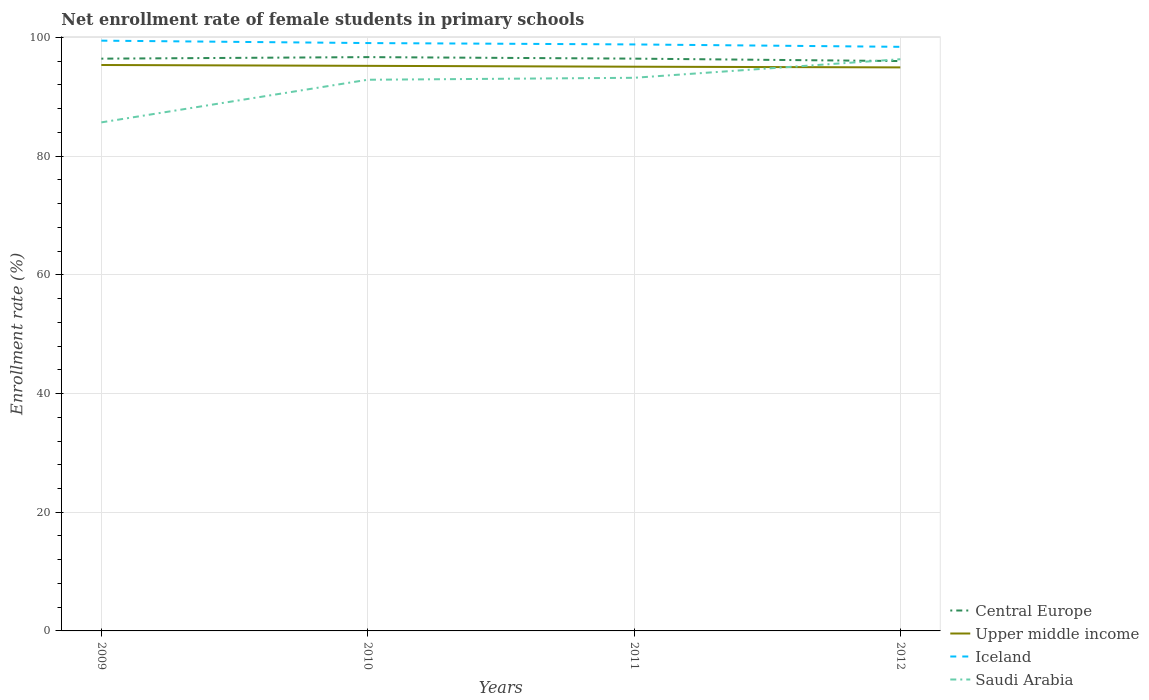How many different coloured lines are there?
Your answer should be compact. 4. Does the line corresponding to Central Europe intersect with the line corresponding to Saudi Arabia?
Your response must be concise. Yes. Across all years, what is the maximum net enrollment rate of female students in primary schools in Upper middle income?
Your response must be concise. 94.97. In which year was the net enrollment rate of female students in primary schools in Upper middle income maximum?
Make the answer very short. 2012. What is the total net enrollment rate of female students in primary schools in Saudi Arabia in the graph?
Give a very brief answer. -10.64. What is the difference between the highest and the second highest net enrollment rate of female students in primary schools in Iceland?
Your answer should be very brief. 1.04. What is the difference between the highest and the lowest net enrollment rate of female students in primary schools in Iceland?
Offer a very short reply. 2. Is the net enrollment rate of female students in primary schools in Iceland strictly greater than the net enrollment rate of female students in primary schools in Upper middle income over the years?
Offer a very short reply. No. How many lines are there?
Provide a succinct answer. 4. What is the difference between two consecutive major ticks on the Y-axis?
Your response must be concise. 20. Are the values on the major ticks of Y-axis written in scientific E-notation?
Make the answer very short. No. Does the graph contain any zero values?
Offer a very short reply. No. Does the graph contain grids?
Give a very brief answer. Yes. What is the title of the graph?
Provide a succinct answer. Net enrollment rate of female students in primary schools. What is the label or title of the X-axis?
Offer a terse response. Years. What is the label or title of the Y-axis?
Your answer should be compact. Enrollment rate (%). What is the Enrollment rate (%) in Central Europe in 2009?
Offer a very short reply. 96.44. What is the Enrollment rate (%) in Upper middle income in 2009?
Make the answer very short. 95.37. What is the Enrollment rate (%) of Iceland in 2009?
Ensure brevity in your answer.  99.47. What is the Enrollment rate (%) of Saudi Arabia in 2009?
Keep it short and to the point. 85.7. What is the Enrollment rate (%) in Central Europe in 2010?
Provide a short and direct response. 96.7. What is the Enrollment rate (%) in Upper middle income in 2010?
Keep it short and to the point. 95.23. What is the Enrollment rate (%) in Iceland in 2010?
Your response must be concise. 99.07. What is the Enrollment rate (%) of Saudi Arabia in 2010?
Keep it short and to the point. 92.88. What is the Enrollment rate (%) in Central Europe in 2011?
Ensure brevity in your answer.  96.44. What is the Enrollment rate (%) of Upper middle income in 2011?
Make the answer very short. 95.08. What is the Enrollment rate (%) of Iceland in 2011?
Keep it short and to the point. 98.84. What is the Enrollment rate (%) of Saudi Arabia in 2011?
Give a very brief answer. 93.21. What is the Enrollment rate (%) in Central Europe in 2012?
Your response must be concise. 96.03. What is the Enrollment rate (%) in Upper middle income in 2012?
Ensure brevity in your answer.  94.97. What is the Enrollment rate (%) of Iceland in 2012?
Your response must be concise. 98.43. What is the Enrollment rate (%) in Saudi Arabia in 2012?
Provide a short and direct response. 96.35. Across all years, what is the maximum Enrollment rate (%) of Central Europe?
Ensure brevity in your answer.  96.7. Across all years, what is the maximum Enrollment rate (%) of Upper middle income?
Your response must be concise. 95.37. Across all years, what is the maximum Enrollment rate (%) of Iceland?
Make the answer very short. 99.47. Across all years, what is the maximum Enrollment rate (%) in Saudi Arabia?
Your answer should be very brief. 96.35. Across all years, what is the minimum Enrollment rate (%) in Central Europe?
Keep it short and to the point. 96.03. Across all years, what is the minimum Enrollment rate (%) in Upper middle income?
Your answer should be compact. 94.97. Across all years, what is the minimum Enrollment rate (%) of Iceland?
Your answer should be compact. 98.43. Across all years, what is the minimum Enrollment rate (%) in Saudi Arabia?
Keep it short and to the point. 85.7. What is the total Enrollment rate (%) of Central Europe in the graph?
Give a very brief answer. 385.61. What is the total Enrollment rate (%) of Upper middle income in the graph?
Your answer should be compact. 380.65. What is the total Enrollment rate (%) of Iceland in the graph?
Offer a terse response. 395.81. What is the total Enrollment rate (%) in Saudi Arabia in the graph?
Your response must be concise. 368.14. What is the difference between the Enrollment rate (%) of Central Europe in 2009 and that in 2010?
Your answer should be compact. -0.26. What is the difference between the Enrollment rate (%) in Upper middle income in 2009 and that in 2010?
Provide a short and direct response. 0.14. What is the difference between the Enrollment rate (%) of Iceland in 2009 and that in 2010?
Provide a succinct answer. 0.4. What is the difference between the Enrollment rate (%) of Saudi Arabia in 2009 and that in 2010?
Your response must be concise. -7.18. What is the difference between the Enrollment rate (%) of Central Europe in 2009 and that in 2011?
Your answer should be compact. -0.01. What is the difference between the Enrollment rate (%) in Upper middle income in 2009 and that in 2011?
Provide a succinct answer. 0.29. What is the difference between the Enrollment rate (%) of Iceland in 2009 and that in 2011?
Offer a very short reply. 0.64. What is the difference between the Enrollment rate (%) of Saudi Arabia in 2009 and that in 2011?
Give a very brief answer. -7.51. What is the difference between the Enrollment rate (%) in Central Europe in 2009 and that in 2012?
Give a very brief answer. 0.4. What is the difference between the Enrollment rate (%) in Upper middle income in 2009 and that in 2012?
Give a very brief answer. 0.4. What is the difference between the Enrollment rate (%) in Iceland in 2009 and that in 2012?
Provide a succinct answer. 1.04. What is the difference between the Enrollment rate (%) of Saudi Arabia in 2009 and that in 2012?
Provide a succinct answer. -10.64. What is the difference between the Enrollment rate (%) of Central Europe in 2010 and that in 2011?
Give a very brief answer. 0.26. What is the difference between the Enrollment rate (%) in Upper middle income in 2010 and that in 2011?
Ensure brevity in your answer.  0.15. What is the difference between the Enrollment rate (%) in Iceland in 2010 and that in 2011?
Offer a very short reply. 0.23. What is the difference between the Enrollment rate (%) in Saudi Arabia in 2010 and that in 2011?
Offer a very short reply. -0.33. What is the difference between the Enrollment rate (%) of Central Europe in 2010 and that in 2012?
Offer a very short reply. 0.66. What is the difference between the Enrollment rate (%) of Upper middle income in 2010 and that in 2012?
Offer a very short reply. 0.26. What is the difference between the Enrollment rate (%) of Iceland in 2010 and that in 2012?
Provide a short and direct response. 0.64. What is the difference between the Enrollment rate (%) in Saudi Arabia in 2010 and that in 2012?
Offer a very short reply. -3.46. What is the difference between the Enrollment rate (%) of Central Europe in 2011 and that in 2012?
Your response must be concise. 0.41. What is the difference between the Enrollment rate (%) of Upper middle income in 2011 and that in 2012?
Provide a succinct answer. 0.12. What is the difference between the Enrollment rate (%) of Iceland in 2011 and that in 2012?
Keep it short and to the point. 0.4. What is the difference between the Enrollment rate (%) in Saudi Arabia in 2011 and that in 2012?
Your answer should be very brief. -3.13. What is the difference between the Enrollment rate (%) in Central Europe in 2009 and the Enrollment rate (%) in Upper middle income in 2010?
Offer a very short reply. 1.21. What is the difference between the Enrollment rate (%) in Central Europe in 2009 and the Enrollment rate (%) in Iceland in 2010?
Provide a succinct answer. -2.63. What is the difference between the Enrollment rate (%) of Central Europe in 2009 and the Enrollment rate (%) of Saudi Arabia in 2010?
Ensure brevity in your answer.  3.56. What is the difference between the Enrollment rate (%) of Upper middle income in 2009 and the Enrollment rate (%) of Iceland in 2010?
Provide a short and direct response. -3.7. What is the difference between the Enrollment rate (%) of Upper middle income in 2009 and the Enrollment rate (%) of Saudi Arabia in 2010?
Provide a short and direct response. 2.49. What is the difference between the Enrollment rate (%) of Iceland in 2009 and the Enrollment rate (%) of Saudi Arabia in 2010?
Your answer should be very brief. 6.59. What is the difference between the Enrollment rate (%) of Central Europe in 2009 and the Enrollment rate (%) of Upper middle income in 2011?
Ensure brevity in your answer.  1.36. What is the difference between the Enrollment rate (%) of Central Europe in 2009 and the Enrollment rate (%) of Iceland in 2011?
Ensure brevity in your answer.  -2.4. What is the difference between the Enrollment rate (%) of Central Europe in 2009 and the Enrollment rate (%) of Saudi Arabia in 2011?
Give a very brief answer. 3.22. What is the difference between the Enrollment rate (%) in Upper middle income in 2009 and the Enrollment rate (%) in Iceland in 2011?
Provide a short and direct response. -3.47. What is the difference between the Enrollment rate (%) in Upper middle income in 2009 and the Enrollment rate (%) in Saudi Arabia in 2011?
Provide a succinct answer. 2.16. What is the difference between the Enrollment rate (%) of Iceland in 2009 and the Enrollment rate (%) of Saudi Arabia in 2011?
Keep it short and to the point. 6.26. What is the difference between the Enrollment rate (%) of Central Europe in 2009 and the Enrollment rate (%) of Upper middle income in 2012?
Offer a very short reply. 1.47. What is the difference between the Enrollment rate (%) in Central Europe in 2009 and the Enrollment rate (%) in Iceland in 2012?
Your response must be concise. -1.99. What is the difference between the Enrollment rate (%) in Central Europe in 2009 and the Enrollment rate (%) in Saudi Arabia in 2012?
Provide a short and direct response. 0.09. What is the difference between the Enrollment rate (%) in Upper middle income in 2009 and the Enrollment rate (%) in Iceland in 2012?
Ensure brevity in your answer.  -3.06. What is the difference between the Enrollment rate (%) of Upper middle income in 2009 and the Enrollment rate (%) of Saudi Arabia in 2012?
Make the answer very short. -0.98. What is the difference between the Enrollment rate (%) of Iceland in 2009 and the Enrollment rate (%) of Saudi Arabia in 2012?
Make the answer very short. 3.13. What is the difference between the Enrollment rate (%) in Central Europe in 2010 and the Enrollment rate (%) in Upper middle income in 2011?
Keep it short and to the point. 1.62. What is the difference between the Enrollment rate (%) in Central Europe in 2010 and the Enrollment rate (%) in Iceland in 2011?
Your answer should be compact. -2.14. What is the difference between the Enrollment rate (%) in Central Europe in 2010 and the Enrollment rate (%) in Saudi Arabia in 2011?
Your response must be concise. 3.49. What is the difference between the Enrollment rate (%) in Upper middle income in 2010 and the Enrollment rate (%) in Iceland in 2011?
Ensure brevity in your answer.  -3.61. What is the difference between the Enrollment rate (%) in Upper middle income in 2010 and the Enrollment rate (%) in Saudi Arabia in 2011?
Your answer should be compact. 2.01. What is the difference between the Enrollment rate (%) of Iceland in 2010 and the Enrollment rate (%) of Saudi Arabia in 2011?
Your response must be concise. 5.85. What is the difference between the Enrollment rate (%) of Central Europe in 2010 and the Enrollment rate (%) of Upper middle income in 2012?
Ensure brevity in your answer.  1.73. What is the difference between the Enrollment rate (%) in Central Europe in 2010 and the Enrollment rate (%) in Iceland in 2012?
Keep it short and to the point. -1.73. What is the difference between the Enrollment rate (%) in Central Europe in 2010 and the Enrollment rate (%) in Saudi Arabia in 2012?
Give a very brief answer. 0.35. What is the difference between the Enrollment rate (%) of Upper middle income in 2010 and the Enrollment rate (%) of Iceland in 2012?
Keep it short and to the point. -3.2. What is the difference between the Enrollment rate (%) in Upper middle income in 2010 and the Enrollment rate (%) in Saudi Arabia in 2012?
Your answer should be very brief. -1.12. What is the difference between the Enrollment rate (%) of Iceland in 2010 and the Enrollment rate (%) of Saudi Arabia in 2012?
Give a very brief answer. 2.72. What is the difference between the Enrollment rate (%) in Central Europe in 2011 and the Enrollment rate (%) in Upper middle income in 2012?
Provide a succinct answer. 1.48. What is the difference between the Enrollment rate (%) in Central Europe in 2011 and the Enrollment rate (%) in Iceland in 2012?
Provide a succinct answer. -1.99. What is the difference between the Enrollment rate (%) of Central Europe in 2011 and the Enrollment rate (%) of Saudi Arabia in 2012?
Make the answer very short. 0.1. What is the difference between the Enrollment rate (%) in Upper middle income in 2011 and the Enrollment rate (%) in Iceland in 2012?
Offer a very short reply. -3.35. What is the difference between the Enrollment rate (%) of Upper middle income in 2011 and the Enrollment rate (%) of Saudi Arabia in 2012?
Keep it short and to the point. -1.26. What is the difference between the Enrollment rate (%) in Iceland in 2011 and the Enrollment rate (%) in Saudi Arabia in 2012?
Your answer should be very brief. 2.49. What is the average Enrollment rate (%) in Central Europe per year?
Your answer should be very brief. 96.4. What is the average Enrollment rate (%) of Upper middle income per year?
Your answer should be compact. 95.16. What is the average Enrollment rate (%) of Iceland per year?
Provide a succinct answer. 98.95. What is the average Enrollment rate (%) in Saudi Arabia per year?
Provide a succinct answer. 92.04. In the year 2009, what is the difference between the Enrollment rate (%) in Central Europe and Enrollment rate (%) in Upper middle income?
Give a very brief answer. 1.07. In the year 2009, what is the difference between the Enrollment rate (%) of Central Europe and Enrollment rate (%) of Iceland?
Keep it short and to the point. -3.03. In the year 2009, what is the difference between the Enrollment rate (%) in Central Europe and Enrollment rate (%) in Saudi Arabia?
Give a very brief answer. 10.74. In the year 2009, what is the difference between the Enrollment rate (%) of Upper middle income and Enrollment rate (%) of Iceland?
Keep it short and to the point. -4.1. In the year 2009, what is the difference between the Enrollment rate (%) in Upper middle income and Enrollment rate (%) in Saudi Arabia?
Make the answer very short. 9.67. In the year 2009, what is the difference between the Enrollment rate (%) in Iceland and Enrollment rate (%) in Saudi Arabia?
Provide a succinct answer. 13.77. In the year 2010, what is the difference between the Enrollment rate (%) in Central Europe and Enrollment rate (%) in Upper middle income?
Provide a succinct answer. 1.47. In the year 2010, what is the difference between the Enrollment rate (%) in Central Europe and Enrollment rate (%) in Iceland?
Your answer should be very brief. -2.37. In the year 2010, what is the difference between the Enrollment rate (%) of Central Europe and Enrollment rate (%) of Saudi Arabia?
Give a very brief answer. 3.82. In the year 2010, what is the difference between the Enrollment rate (%) of Upper middle income and Enrollment rate (%) of Iceland?
Ensure brevity in your answer.  -3.84. In the year 2010, what is the difference between the Enrollment rate (%) in Upper middle income and Enrollment rate (%) in Saudi Arabia?
Your answer should be compact. 2.34. In the year 2010, what is the difference between the Enrollment rate (%) of Iceland and Enrollment rate (%) of Saudi Arabia?
Keep it short and to the point. 6.18. In the year 2011, what is the difference between the Enrollment rate (%) in Central Europe and Enrollment rate (%) in Upper middle income?
Your answer should be compact. 1.36. In the year 2011, what is the difference between the Enrollment rate (%) of Central Europe and Enrollment rate (%) of Iceland?
Your response must be concise. -2.39. In the year 2011, what is the difference between the Enrollment rate (%) in Central Europe and Enrollment rate (%) in Saudi Arabia?
Your response must be concise. 3.23. In the year 2011, what is the difference between the Enrollment rate (%) of Upper middle income and Enrollment rate (%) of Iceland?
Provide a succinct answer. -3.75. In the year 2011, what is the difference between the Enrollment rate (%) in Upper middle income and Enrollment rate (%) in Saudi Arabia?
Your answer should be compact. 1.87. In the year 2011, what is the difference between the Enrollment rate (%) in Iceland and Enrollment rate (%) in Saudi Arabia?
Offer a very short reply. 5.62. In the year 2012, what is the difference between the Enrollment rate (%) in Central Europe and Enrollment rate (%) in Upper middle income?
Provide a short and direct response. 1.07. In the year 2012, what is the difference between the Enrollment rate (%) in Central Europe and Enrollment rate (%) in Iceland?
Make the answer very short. -2.4. In the year 2012, what is the difference between the Enrollment rate (%) in Central Europe and Enrollment rate (%) in Saudi Arabia?
Keep it short and to the point. -0.31. In the year 2012, what is the difference between the Enrollment rate (%) in Upper middle income and Enrollment rate (%) in Iceland?
Your response must be concise. -3.47. In the year 2012, what is the difference between the Enrollment rate (%) of Upper middle income and Enrollment rate (%) of Saudi Arabia?
Offer a terse response. -1.38. In the year 2012, what is the difference between the Enrollment rate (%) in Iceland and Enrollment rate (%) in Saudi Arabia?
Provide a short and direct response. 2.09. What is the ratio of the Enrollment rate (%) in Central Europe in 2009 to that in 2010?
Provide a short and direct response. 1. What is the ratio of the Enrollment rate (%) in Iceland in 2009 to that in 2010?
Provide a short and direct response. 1. What is the ratio of the Enrollment rate (%) of Saudi Arabia in 2009 to that in 2010?
Make the answer very short. 0.92. What is the ratio of the Enrollment rate (%) in Central Europe in 2009 to that in 2011?
Your answer should be very brief. 1. What is the ratio of the Enrollment rate (%) in Upper middle income in 2009 to that in 2011?
Ensure brevity in your answer.  1. What is the ratio of the Enrollment rate (%) of Iceland in 2009 to that in 2011?
Your answer should be very brief. 1.01. What is the ratio of the Enrollment rate (%) of Saudi Arabia in 2009 to that in 2011?
Keep it short and to the point. 0.92. What is the ratio of the Enrollment rate (%) of Central Europe in 2009 to that in 2012?
Make the answer very short. 1. What is the ratio of the Enrollment rate (%) of Iceland in 2009 to that in 2012?
Ensure brevity in your answer.  1.01. What is the ratio of the Enrollment rate (%) in Saudi Arabia in 2009 to that in 2012?
Provide a short and direct response. 0.89. What is the ratio of the Enrollment rate (%) of Central Europe in 2010 to that in 2011?
Provide a succinct answer. 1. What is the ratio of the Enrollment rate (%) of Central Europe in 2010 to that in 2012?
Make the answer very short. 1.01. What is the ratio of the Enrollment rate (%) of Upper middle income in 2010 to that in 2012?
Provide a succinct answer. 1. What is the ratio of the Enrollment rate (%) of Iceland in 2010 to that in 2012?
Provide a short and direct response. 1.01. What is the ratio of the Enrollment rate (%) in Saudi Arabia in 2010 to that in 2012?
Your response must be concise. 0.96. What is the ratio of the Enrollment rate (%) in Saudi Arabia in 2011 to that in 2012?
Provide a succinct answer. 0.97. What is the difference between the highest and the second highest Enrollment rate (%) in Central Europe?
Offer a terse response. 0.26. What is the difference between the highest and the second highest Enrollment rate (%) in Upper middle income?
Offer a very short reply. 0.14. What is the difference between the highest and the second highest Enrollment rate (%) in Iceland?
Keep it short and to the point. 0.4. What is the difference between the highest and the second highest Enrollment rate (%) in Saudi Arabia?
Offer a terse response. 3.13. What is the difference between the highest and the lowest Enrollment rate (%) in Central Europe?
Offer a terse response. 0.66. What is the difference between the highest and the lowest Enrollment rate (%) of Upper middle income?
Offer a terse response. 0.4. What is the difference between the highest and the lowest Enrollment rate (%) of Saudi Arabia?
Make the answer very short. 10.64. 